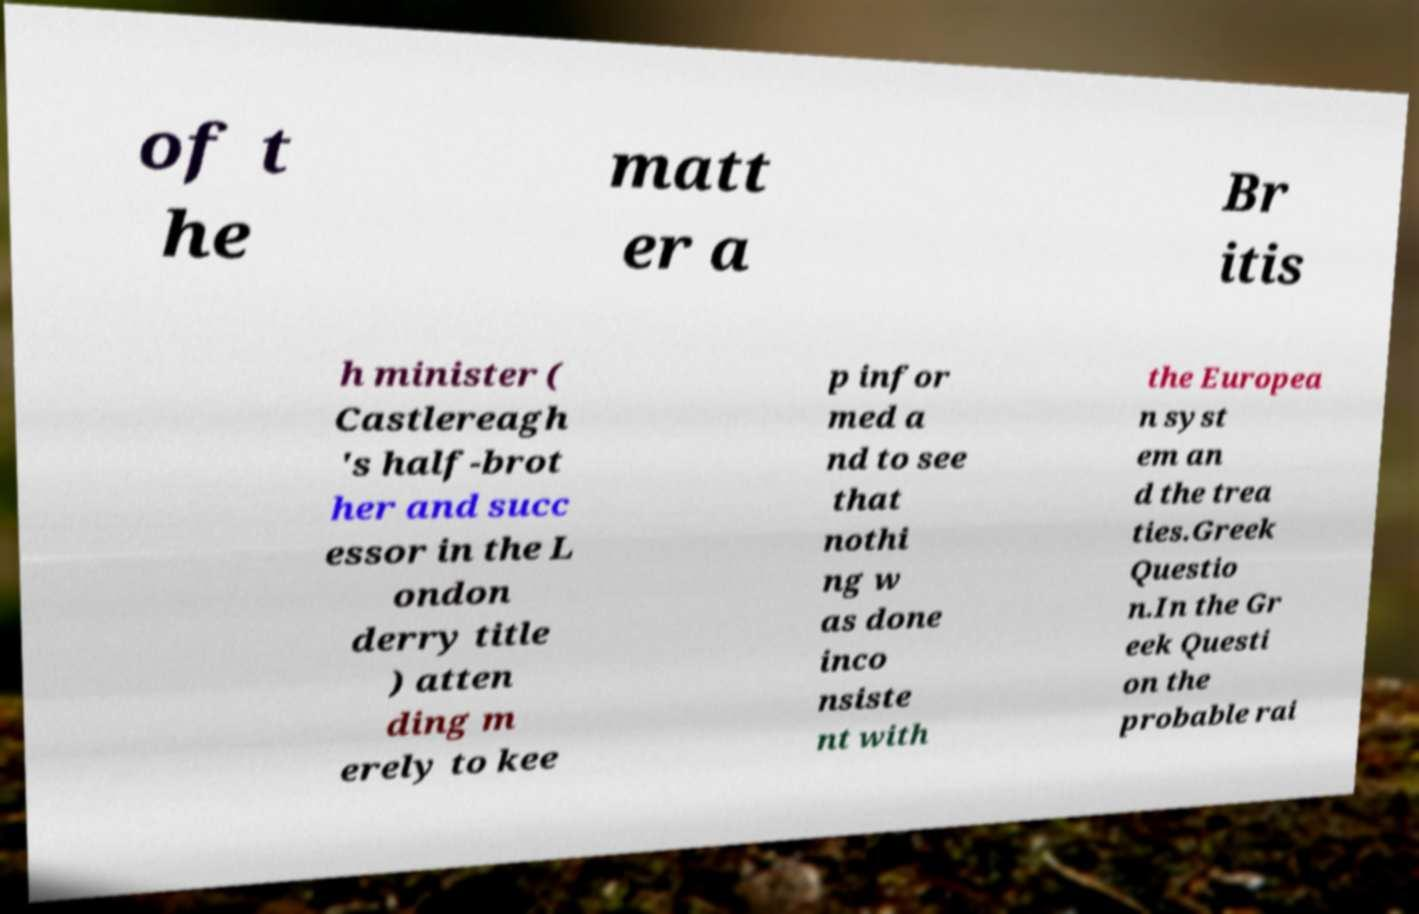Please identify and transcribe the text found in this image. of t he matt er a Br itis h minister ( Castlereagh 's half-brot her and succ essor in the L ondon derry title ) atten ding m erely to kee p infor med a nd to see that nothi ng w as done inco nsiste nt with the Europea n syst em an d the trea ties.Greek Questio n.In the Gr eek Questi on the probable rai 